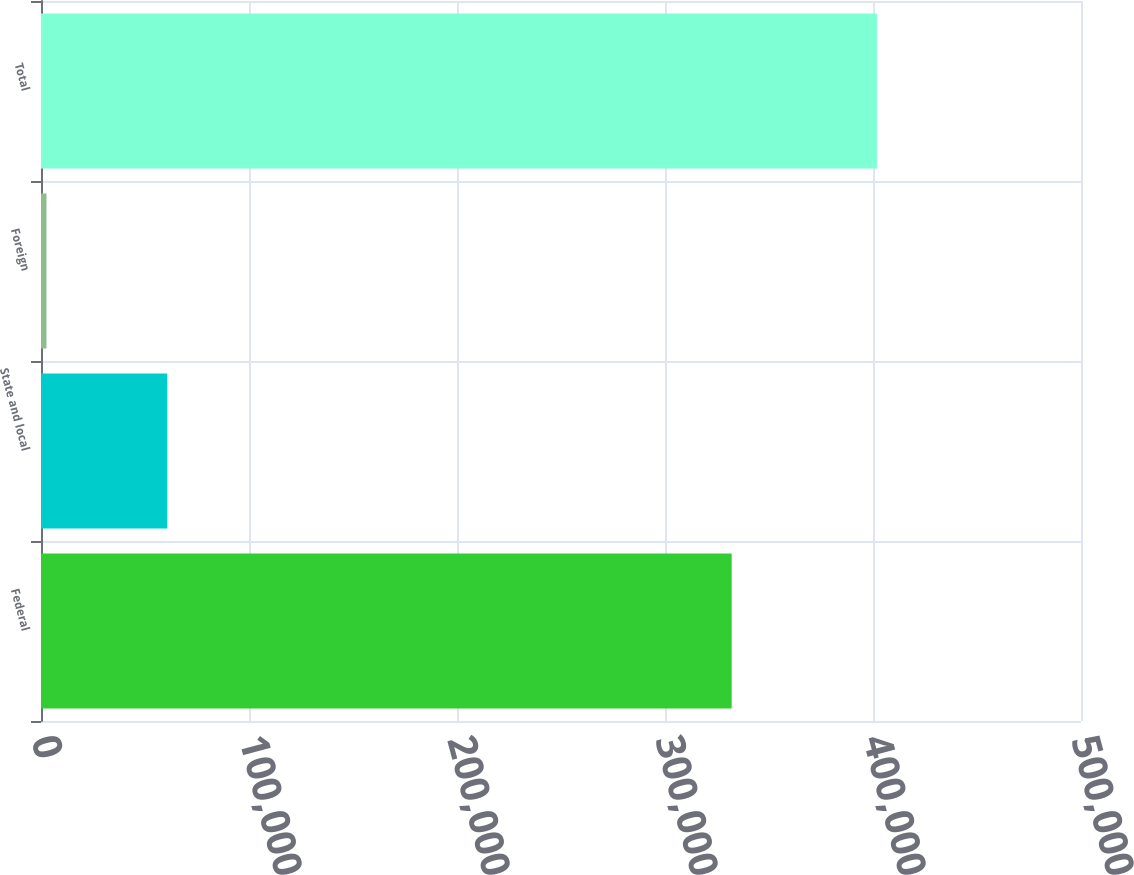<chart> <loc_0><loc_0><loc_500><loc_500><bar_chart><fcel>Federal<fcel>State and local<fcel>Foreign<fcel>Total<nl><fcel>332053<fcel>60708<fcel>2649<fcel>401897<nl></chart> 